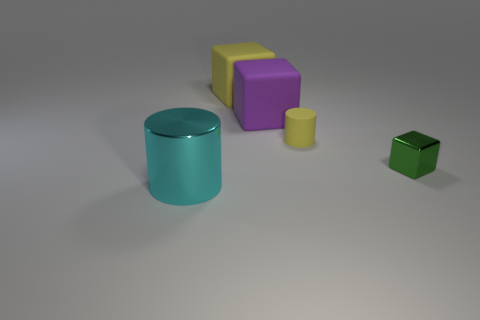Subtract 1 blocks. How many blocks are left? 2 Add 3 tiny metallic cylinders. How many objects exist? 8 Subtract all cylinders. How many objects are left? 3 Add 5 gray metal objects. How many gray metal objects exist? 5 Subtract 0 yellow balls. How many objects are left? 5 Subtract all large brown things. Subtract all yellow blocks. How many objects are left? 4 Add 5 rubber cubes. How many rubber cubes are left? 7 